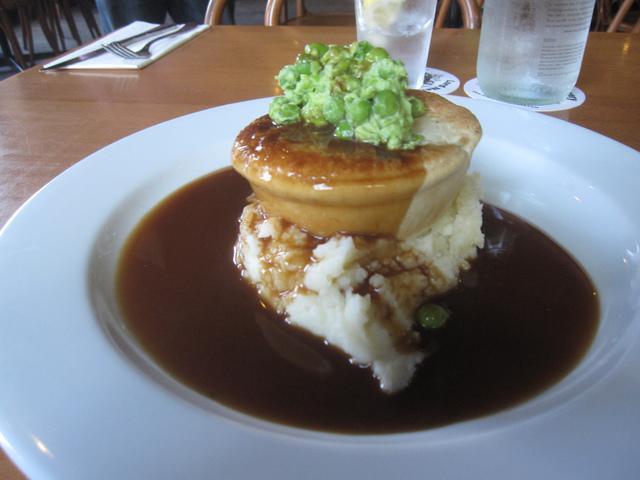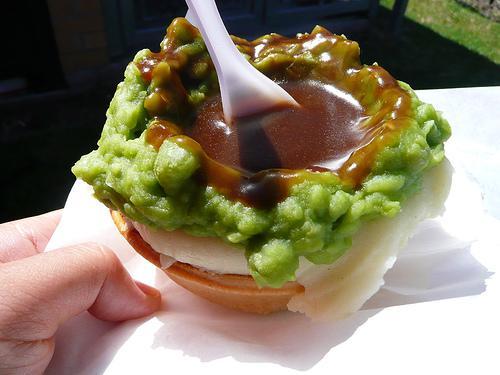The first image is the image on the left, the second image is the image on the right. Analyze the images presented: Is the assertion "One image shows a white utensil sticking out of a pool of brown gravy in a pile of mashed green food on mashed white food in a pastry crust." valid? Answer yes or no. Yes. The first image is the image on the left, the second image is the image on the right. Analyze the images presented: Is the assertion "In one of the images, a spoon is stuck into the top of the food." valid? Answer yes or no. Yes. 